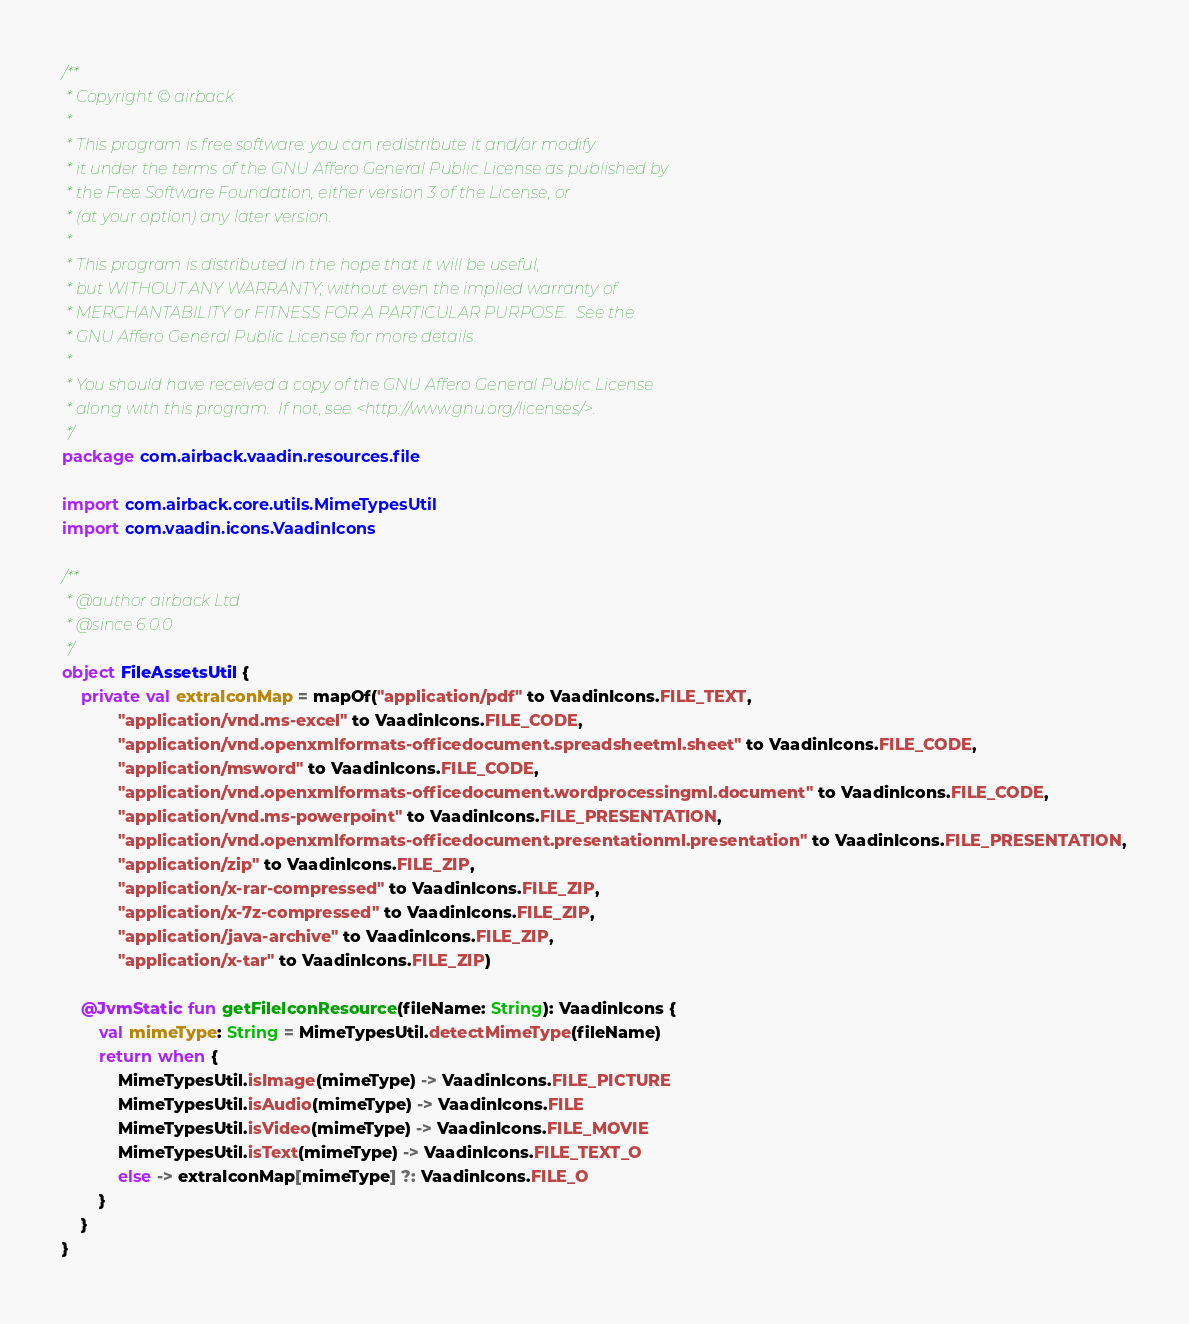<code> <loc_0><loc_0><loc_500><loc_500><_Kotlin_>/**
 * Copyright © airback
 *
 * This program is free software: you can redistribute it and/or modify
 * it under the terms of the GNU Affero General Public License as published by
 * the Free Software Foundation, either version 3 of the License, or
 * (at your option) any later version.
 *
 * This program is distributed in the hope that it will be useful,
 * but WITHOUT ANY WARRANTY; without even the implied warranty of
 * MERCHANTABILITY or FITNESS FOR A PARTICULAR PURPOSE.  See the
 * GNU Affero General Public License for more details.
 *
 * You should have received a copy of the GNU Affero General Public License
 * along with this program.  If not, see <http://www.gnu.org/licenses/>.
 */
package com.airback.vaadin.resources.file

import com.airback.core.utils.MimeTypesUtil
import com.vaadin.icons.VaadinIcons

/**
 * @author airback Ltd
 * @since 6.0.0
 */
object FileAssetsUtil {
    private val extraIconMap = mapOf("application/pdf" to VaadinIcons.FILE_TEXT,
            "application/vnd.ms-excel" to VaadinIcons.FILE_CODE,
            "application/vnd.openxmlformats-officedocument.spreadsheetml.sheet" to VaadinIcons.FILE_CODE,
            "application/msword" to VaadinIcons.FILE_CODE,
            "application/vnd.openxmlformats-officedocument.wordprocessingml.document" to VaadinIcons.FILE_CODE,
            "application/vnd.ms-powerpoint" to VaadinIcons.FILE_PRESENTATION,
            "application/vnd.openxmlformats-officedocument.presentationml.presentation" to VaadinIcons.FILE_PRESENTATION,
            "application/zip" to VaadinIcons.FILE_ZIP,
            "application/x-rar-compressed" to VaadinIcons.FILE_ZIP,
            "application/x-7z-compressed" to VaadinIcons.FILE_ZIP,
            "application/java-archive" to VaadinIcons.FILE_ZIP,
            "application/x-tar" to VaadinIcons.FILE_ZIP)

    @JvmStatic fun getFileIconResource(fileName: String): VaadinIcons {
        val mimeType: String = MimeTypesUtil.detectMimeType(fileName)
        return when {
            MimeTypesUtil.isImage(mimeType) -> VaadinIcons.FILE_PICTURE
            MimeTypesUtil.isAudio(mimeType) -> VaadinIcons.FILE
            MimeTypesUtil.isVideo(mimeType) -> VaadinIcons.FILE_MOVIE
            MimeTypesUtil.isText(mimeType) -> VaadinIcons.FILE_TEXT_O
            else -> extraIconMap[mimeType] ?: VaadinIcons.FILE_O
        }
    }
}</code> 